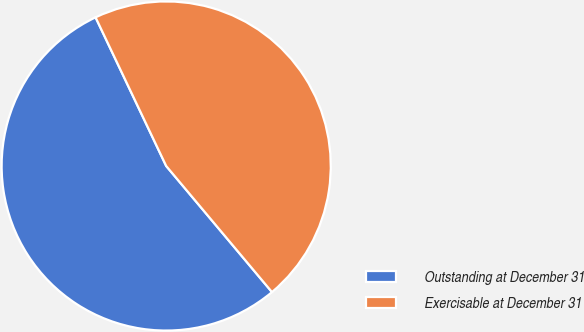Convert chart. <chart><loc_0><loc_0><loc_500><loc_500><pie_chart><fcel>Outstanding at December 31<fcel>Exercisable at December 31<nl><fcel>54.05%<fcel>45.95%<nl></chart> 